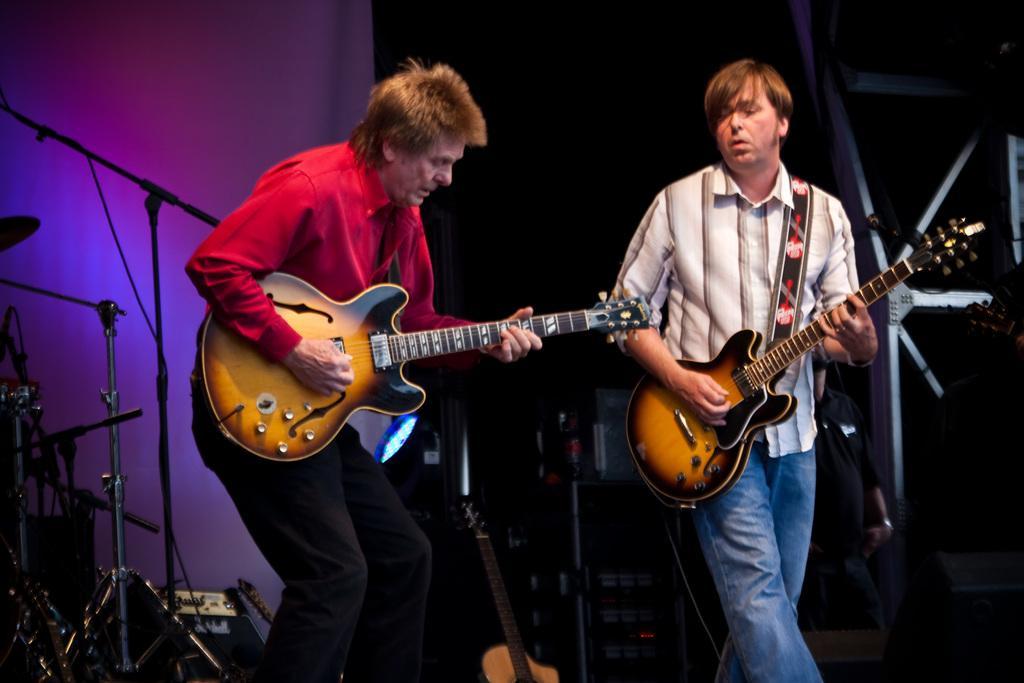Can you describe this image briefly? Here 2 men are standing and playing guitar. Behind them there are musical instruments and microphone. 